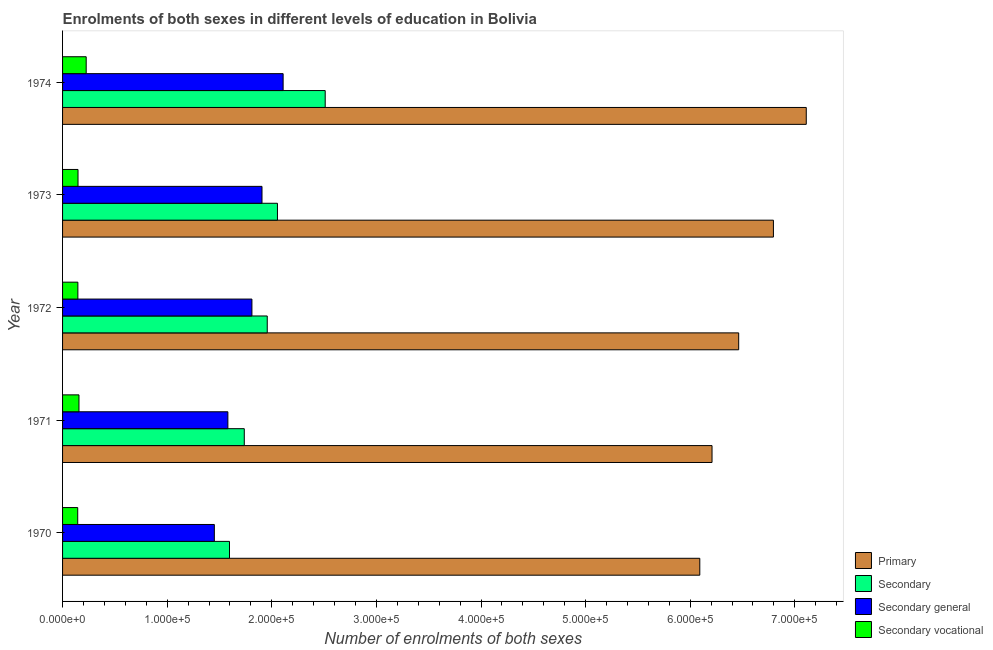How many different coloured bars are there?
Make the answer very short. 4. How many groups of bars are there?
Your answer should be compact. 5. Are the number of bars per tick equal to the number of legend labels?
Your response must be concise. Yes. How many bars are there on the 1st tick from the bottom?
Make the answer very short. 4. What is the label of the 3rd group of bars from the top?
Keep it short and to the point. 1972. What is the number of enrolments in secondary general education in 1970?
Your answer should be very brief. 1.45e+05. Across all years, what is the maximum number of enrolments in secondary vocational education?
Provide a short and direct response. 2.26e+04. Across all years, what is the minimum number of enrolments in secondary vocational education?
Your response must be concise. 1.45e+04. In which year was the number of enrolments in secondary vocational education maximum?
Make the answer very short. 1974. In which year was the number of enrolments in primary education minimum?
Offer a terse response. 1970. What is the total number of enrolments in primary education in the graph?
Provide a succinct answer. 3.27e+06. What is the difference between the number of enrolments in secondary general education in 1970 and that in 1974?
Provide a succinct answer. -6.57e+04. What is the difference between the number of enrolments in secondary education in 1973 and the number of enrolments in secondary general education in 1971?
Provide a short and direct response. 4.74e+04. What is the average number of enrolments in primary education per year?
Provide a short and direct response. 6.53e+05. In the year 1974, what is the difference between the number of enrolments in primary education and number of enrolments in secondary education?
Provide a short and direct response. 4.60e+05. What is the ratio of the number of enrolments in secondary education in 1972 to that in 1973?
Give a very brief answer. 0.95. What is the difference between the highest and the second highest number of enrolments in secondary vocational education?
Your answer should be compact. 6914. What is the difference between the highest and the lowest number of enrolments in secondary vocational education?
Your answer should be very brief. 8103. In how many years, is the number of enrolments in secondary vocational education greater than the average number of enrolments in secondary vocational education taken over all years?
Keep it short and to the point. 1. Is it the case that in every year, the sum of the number of enrolments in secondary general education and number of enrolments in secondary education is greater than the sum of number of enrolments in secondary vocational education and number of enrolments in primary education?
Offer a terse response. No. What does the 3rd bar from the top in 1973 represents?
Your response must be concise. Secondary. What does the 2nd bar from the bottom in 1971 represents?
Provide a succinct answer. Secondary. Is it the case that in every year, the sum of the number of enrolments in primary education and number of enrolments in secondary education is greater than the number of enrolments in secondary general education?
Your answer should be compact. Yes. How many bars are there?
Your response must be concise. 20. How many years are there in the graph?
Ensure brevity in your answer.  5. Does the graph contain any zero values?
Give a very brief answer. No. Where does the legend appear in the graph?
Offer a very short reply. Bottom right. How many legend labels are there?
Offer a terse response. 4. How are the legend labels stacked?
Provide a succinct answer. Vertical. What is the title of the graph?
Your answer should be very brief. Enrolments of both sexes in different levels of education in Bolivia. What is the label or title of the X-axis?
Keep it short and to the point. Number of enrolments of both sexes. What is the label or title of the Y-axis?
Offer a terse response. Year. What is the Number of enrolments of both sexes of Primary in 1970?
Ensure brevity in your answer.  6.09e+05. What is the Number of enrolments of both sexes in Secondary in 1970?
Ensure brevity in your answer.  1.60e+05. What is the Number of enrolments of both sexes in Secondary general in 1970?
Make the answer very short. 1.45e+05. What is the Number of enrolments of both sexes of Secondary vocational in 1970?
Keep it short and to the point. 1.45e+04. What is the Number of enrolments of both sexes in Primary in 1971?
Make the answer very short. 6.21e+05. What is the Number of enrolments of both sexes in Secondary in 1971?
Ensure brevity in your answer.  1.74e+05. What is the Number of enrolments of both sexes of Secondary general in 1971?
Your answer should be very brief. 1.58e+05. What is the Number of enrolments of both sexes in Secondary vocational in 1971?
Your response must be concise. 1.57e+04. What is the Number of enrolments of both sexes in Primary in 1972?
Your answer should be very brief. 6.46e+05. What is the Number of enrolments of both sexes of Secondary in 1972?
Your answer should be very brief. 1.96e+05. What is the Number of enrolments of both sexes of Secondary general in 1972?
Keep it short and to the point. 1.81e+05. What is the Number of enrolments of both sexes in Secondary vocational in 1972?
Ensure brevity in your answer.  1.46e+04. What is the Number of enrolments of both sexes of Primary in 1973?
Your answer should be compact. 6.80e+05. What is the Number of enrolments of both sexes in Secondary in 1973?
Give a very brief answer. 2.05e+05. What is the Number of enrolments of both sexes of Secondary general in 1973?
Provide a short and direct response. 1.91e+05. What is the Number of enrolments of both sexes of Secondary vocational in 1973?
Offer a very short reply. 1.48e+04. What is the Number of enrolments of both sexes in Primary in 1974?
Provide a short and direct response. 7.11e+05. What is the Number of enrolments of both sexes of Secondary in 1974?
Make the answer very short. 2.51e+05. What is the Number of enrolments of both sexes of Secondary general in 1974?
Your answer should be compact. 2.11e+05. What is the Number of enrolments of both sexes of Secondary vocational in 1974?
Provide a succinct answer. 2.26e+04. Across all years, what is the maximum Number of enrolments of both sexes of Primary?
Your answer should be compact. 7.11e+05. Across all years, what is the maximum Number of enrolments of both sexes in Secondary?
Offer a very short reply. 2.51e+05. Across all years, what is the maximum Number of enrolments of both sexes of Secondary general?
Provide a succinct answer. 2.11e+05. Across all years, what is the maximum Number of enrolments of both sexes in Secondary vocational?
Your answer should be very brief. 2.26e+04. Across all years, what is the minimum Number of enrolments of both sexes of Primary?
Give a very brief answer. 6.09e+05. Across all years, what is the minimum Number of enrolments of both sexes in Secondary?
Offer a very short reply. 1.60e+05. Across all years, what is the minimum Number of enrolments of both sexes in Secondary general?
Make the answer very short. 1.45e+05. Across all years, what is the minimum Number of enrolments of both sexes in Secondary vocational?
Make the answer very short. 1.45e+04. What is the total Number of enrolments of both sexes of Primary in the graph?
Offer a very short reply. 3.27e+06. What is the total Number of enrolments of both sexes of Secondary in the graph?
Your answer should be compact. 9.85e+05. What is the total Number of enrolments of both sexes in Secondary general in the graph?
Offer a terse response. 8.86e+05. What is the total Number of enrolments of both sexes of Secondary vocational in the graph?
Provide a succinct answer. 8.22e+04. What is the difference between the Number of enrolments of both sexes of Primary in 1970 and that in 1971?
Ensure brevity in your answer.  -1.17e+04. What is the difference between the Number of enrolments of both sexes in Secondary in 1970 and that in 1971?
Your response must be concise. -1.41e+04. What is the difference between the Number of enrolments of both sexes of Secondary general in 1970 and that in 1971?
Provide a succinct answer. -1.29e+04. What is the difference between the Number of enrolments of both sexes of Secondary vocational in 1970 and that in 1971?
Ensure brevity in your answer.  -1189. What is the difference between the Number of enrolments of both sexes of Primary in 1970 and that in 1972?
Give a very brief answer. -3.72e+04. What is the difference between the Number of enrolments of both sexes in Secondary in 1970 and that in 1972?
Ensure brevity in your answer.  -3.61e+04. What is the difference between the Number of enrolments of both sexes of Secondary general in 1970 and that in 1972?
Your answer should be very brief. -3.59e+04. What is the difference between the Number of enrolments of both sexes of Secondary vocational in 1970 and that in 1972?
Ensure brevity in your answer.  -157. What is the difference between the Number of enrolments of both sexes in Primary in 1970 and that in 1973?
Ensure brevity in your answer.  -7.04e+04. What is the difference between the Number of enrolments of both sexes in Secondary in 1970 and that in 1973?
Your answer should be very brief. -4.58e+04. What is the difference between the Number of enrolments of both sexes of Secondary general in 1970 and that in 1973?
Your answer should be compact. -4.56e+04. What is the difference between the Number of enrolments of both sexes in Secondary vocational in 1970 and that in 1973?
Your answer should be very brief. -288. What is the difference between the Number of enrolments of both sexes in Primary in 1970 and that in 1974?
Your answer should be very brief. -1.02e+05. What is the difference between the Number of enrolments of both sexes in Secondary in 1970 and that in 1974?
Your answer should be compact. -9.15e+04. What is the difference between the Number of enrolments of both sexes of Secondary general in 1970 and that in 1974?
Offer a very short reply. -6.57e+04. What is the difference between the Number of enrolments of both sexes in Secondary vocational in 1970 and that in 1974?
Keep it short and to the point. -8103. What is the difference between the Number of enrolments of both sexes in Primary in 1971 and that in 1972?
Give a very brief answer. -2.55e+04. What is the difference between the Number of enrolments of both sexes in Secondary in 1971 and that in 1972?
Provide a short and direct response. -2.20e+04. What is the difference between the Number of enrolments of both sexes of Secondary general in 1971 and that in 1972?
Make the answer very short. -2.30e+04. What is the difference between the Number of enrolments of both sexes in Secondary vocational in 1971 and that in 1972?
Keep it short and to the point. 1032. What is the difference between the Number of enrolments of both sexes in Primary in 1971 and that in 1973?
Offer a very short reply. -5.87e+04. What is the difference between the Number of enrolments of both sexes in Secondary in 1971 and that in 1973?
Ensure brevity in your answer.  -3.17e+04. What is the difference between the Number of enrolments of both sexes in Secondary general in 1971 and that in 1973?
Your answer should be compact. -3.26e+04. What is the difference between the Number of enrolments of both sexes in Secondary vocational in 1971 and that in 1973?
Give a very brief answer. 901. What is the difference between the Number of enrolments of both sexes in Primary in 1971 and that in 1974?
Offer a terse response. -9.01e+04. What is the difference between the Number of enrolments of both sexes in Secondary in 1971 and that in 1974?
Your answer should be compact. -7.74e+04. What is the difference between the Number of enrolments of both sexes in Secondary general in 1971 and that in 1974?
Provide a short and direct response. -5.28e+04. What is the difference between the Number of enrolments of both sexes of Secondary vocational in 1971 and that in 1974?
Offer a terse response. -6914. What is the difference between the Number of enrolments of both sexes in Primary in 1972 and that in 1973?
Your answer should be very brief. -3.32e+04. What is the difference between the Number of enrolments of both sexes in Secondary in 1972 and that in 1973?
Provide a short and direct response. -9761. What is the difference between the Number of enrolments of both sexes in Secondary general in 1972 and that in 1973?
Your response must be concise. -9630. What is the difference between the Number of enrolments of both sexes in Secondary vocational in 1972 and that in 1973?
Your answer should be very brief. -131. What is the difference between the Number of enrolments of both sexes of Primary in 1972 and that in 1974?
Make the answer very short. -6.46e+04. What is the difference between the Number of enrolments of both sexes of Secondary in 1972 and that in 1974?
Offer a very short reply. -5.54e+04. What is the difference between the Number of enrolments of both sexes of Secondary general in 1972 and that in 1974?
Your answer should be compact. -2.98e+04. What is the difference between the Number of enrolments of both sexes in Secondary vocational in 1972 and that in 1974?
Keep it short and to the point. -7946. What is the difference between the Number of enrolments of both sexes of Primary in 1973 and that in 1974?
Give a very brief answer. -3.14e+04. What is the difference between the Number of enrolments of both sexes of Secondary in 1973 and that in 1974?
Ensure brevity in your answer.  -4.56e+04. What is the difference between the Number of enrolments of both sexes of Secondary general in 1973 and that in 1974?
Provide a succinct answer. -2.02e+04. What is the difference between the Number of enrolments of both sexes in Secondary vocational in 1973 and that in 1974?
Your response must be concise. -7815. What is the difference between the Number of enrolments of both sexes of Primary in 1970 and the Number of enrolments of both sexes of Secondary in 1971?
Offer a terse response. 4.35e+05. What is the difference between the Number of enrolments of both sexes of Primary in 1970 and the Number of enrolments of both sexes of Secondary general in 1971?
Offer a very short reply. 4.51e+05. What is the difference between the Number of enrolments of both sexes in Primary in 1970 and the Number of enrolments of both sexes in Secondary vocational in 1971?
Ensure brevity in your answer.  5.94e+05. What is the difference between the Number of enrolments of both sexes in Secondary in 1970 and the Number of enrolments of both sexes in Secondary general in 1971?
Your answer should be very brief. 1545. What is the difference between the Number of enrolments of both sexes of Secondary in 1970 and the Number of enrolments of both sexes of Secondary vocational in 1971?
Offer a terse response. 1.44e+05. What is the difference between the Number of enrolments of both sexes in Secondary general in 1970 and the Number of enrolments of both sexes in Secondary vocational in 1971?
Give a very brief answer. 1.29e+05. What is the difference between the Number of enrolments of both sexes of Primary in 1970 and the Number of enrolments of both sexes of Secondary in 1972?
Offer a very short reply. 4.14e+05. What is the difference between the Number of enrolments of both sexes of Primary in 1970 and the Number of enrolments of both sexes of Secondary general in 1972?
Provide a short and direct response. 4.28e+05. What is the difference between the Number of enrolments of both sexes in Primary in 1970 and the Number of enrolments of both sexes in Secondary vocational in 1972?
Provide a succinct answer. 5.95e+05. What is the difference between the Number of enrolments of both sexes of Secondary in 1970 and the Number of enrolments of both sexes of Secondary general in 1972?
Your answer should be very brief. -2.14e+04. What is the difference between the Number of enrolments of both sexes in Secondary in 1970 and the Number of enrolments of both sexes in Secondary vocational in 1972?
Ensure brevity in your answer.  1.45e+05. What is the difference between the Number of enrolments of both sexes in Secondary general in 1970 and the Number of enrolments of both sexes in Secondary vocational in 1972?
Provide a short and direct response. 1.30e+05. What is the difference between the Number of enrolments of both sexes in Primary in 1970 and the Number of enrolments of both sexes in Secondary in 1973?
Provide a short and direct response. 4.04e+05. What is the difference between the Number of enrolments of both sexes of Primary in 1970 and the Number of enrolments of both sexes of Secondary general in 1973?
Provide a succinct answer. 4.19e+05. What is the difference between the Number of enrolments of both sexes of Primary in 1970 and the Number of enrolments of both sexes of Secondary vocational in 1973?
Provide a succinct answer. 5.94e+05. What is the difference between the Number of enrolments of both sexes in Secondary in 1970 and the Number of enrolments of both sexes in Secondary general in 1973?
Provide a short and direct response. -3.11e+04. What is the difference between the Number of enrolments of both sexes of Secondary in 1970 and the Number of enrolments of both sexes of Secondary vocational in 1973?
Offer a very short reply. 1.45e+05. What is the difference between the Number of enrolments of both sexes of Secondary general in 1970 and the Number of enrolments of both sexes of Secondary vocational in 1973?
Make the answer very short. 1.30e+05. What is the difference between the Number of enrolments of both sexes in Primary in 1970 and the Number of enrolments of both sexes in Secondary in 1974?
Provide a short and direct response. 3.58e+05. What is the difference between the Number of enrolments of both sexes of Primary in 1970 and the Number of enrolments of both sexes of Secondary general in 1974?
Make the answer very short. 3.98e+05. What is the difference between the Number of enrolments of both sexes of Primary in 1970 and the Number of enrolments of both sexes of Secondary vocational in 1974?
Offer a terse response. 5.87e+05. What is the difference between the Number of enrolments of both sexes in Secondary in 1970 and the Number of enrolments of both sexes in Secondary general in 1974?
Offer a terse response. -5.13e+04. What is the difference between the Number of enrolments of both sexes of Secondary in 1970 and the Number of enrolments of both sexes of Secondary vocational in 1974?
Make the answer very short. 1.37e+05. What is the difference between the Number of enrolments of both sexes of Secondary general in 1970 and the Number of enrolments of both sexes of Secondary vocational in 1974?
Give a very brief answer. 1.23e+05. What is the difference between the Number of enrolments of both sexes of Primary in 1971 and the Number of enrolments of both sexes of Secondary in 1972?
Make the answer very short. 4.25e+05. What is the difference between the Number of enrolments of both sexes of Primary in 1971 and the Number of enrolments of both sexes of Secondary general in 1972?
Ensure brevity in your answer.  4.40e+05. What is the difference between the Number of enrolments of both sexes in Primary in 1971 and the Number of enrolments of both sexes in Secondary vocational in 1972?
Your answer should be compact. 6.06e+05. What is the difference between the Number of enrolments of both sexes in Secondary in 1971 and the Number of enrolments of both sexes in Secondary general in 1972?
Your response must be concise. -7313. What is the difference between the Number of enrolments of both sexes of Secondary in 1971 and the Number of enrolments of both sexes of Secondary vocational in 1972?
Offer a terse response. 1.59e+05. What is the difference between the Number of enrolments of both sexes in Secondary general in 1971 and the Number of enrolments of both sexes in Secondary vocational in 1972?
Provide a short and direct response. 1.43e+05. What is the difference between the Number of enrolments of both sexes in Primary in 1971 and the Number of enrolments of both sexes in Secondary in 1973?
Make the answer very short. 4.15e+05. What is the difference between the Number of enrolments of both sexes of Primary in 1971 and the Number of enrolments of both sexes of Secondary general in 1973?
Offer a very short reply. 4.30e+05. What is the difference between the Number of enrolments of both sexes in Primary in 1971 and the Number of enrolments of both sexes in Secondary vocational in 1973?
Provide a succinct answer. 6.06e+05. What is the difference between the Number of enrolments of both sexes in Secondary in 1971 and the Number of enrolments of both sexes in Secondary general in 1973?
Offer a very short reply. -1.69e+04. What is the difference between the Number of enrolments of both sexes in Secondary in 1971 and the Number of enrolments of both sexes in Secondary vocational in 1973?
Your answer should be very brief. 1.59e+05. What is the difference between the Number of enrolments of both sexes in Secondary general in 1971 and the Number of enrolments of both sexes in Secondary vocational in 1973?
Make the answer very short. 1.43e+05. What is the difference between the Number of enrolments of both sexes in Primary in 1971 and the Number of enrolments of both sexes in Secondary in 1974?
Your answer should be compact. 3.70e+05. What is the difference between the Number of enrolments of both sexes in Primary in 1971 and the Number of enrolments of both sexes in Secondary general in 1974?
Provide a succinct answer. 4.10e+05. What is the difference between the Number of enrolments of both sexes of Primary in 1971 and the Number of enrolments of both sexes of Secondary vocational in 1974?
Provide a short and direct response. 5.98e+05. What is the difference between the Number of enrolments of both sexes of Secondary in 1971 and the Number of enrolments of both sexes of Secondary general in 1974?
Your response must be concise. -3.71e+04. What is the difference between the Number of enrolments of both sexes of Secondary in 1971 and the Number of enrolments of both sexes of Secondary vocational in 1974?
Ensure brevity in your answer.  1.51e+05. What is the difference between the Number of enrolments of both sexes in Secondary general in 1971 and the Number of enrolments of both sexes in Secondary vocational in 1974?
Offer a very short reply. 1.35e+05. What is the difference between the Number of enrolments of both sexes of Primary in 1972 and the Number of enrolments of both sexes of Secondary in 1973?
Your answer should be very brief. 4.41e+05. What is the difference between the Number of enrolments of both sexes of Primary in 1972 and the Number of enrolments of both sexes of Secondary general in 1973?
Provide a succinct answer. 4.56e+05. What is the difference between the Number of enrolments of both sexes in Primary in 1972 and the Number of enrolments of both sexes in Secondary vocational in 1973?
Offer a very short reply. 6.32e+05. What is the difference between the Number of enrolments of both sexes of Secondary in 1972 and the Number of enrolments of both sexes of Secondary general in 1973?
Your answer should be very brief. 5012. What is the difference between the Number of enrolments of both sexes in Secondary in 1972 and the Number of enrolments of both sexes in Secondary vocational in 1973?
Provide a succinct answer. 1.81e+05. What is the difference between the Number of enrolments of both sexes of Secondary general in 1972 and the Number of enrolments of both sexes of Secondary vocational in 1973?
Your answer should be very brief. 1.66e+05. What is the difference between the Number of enrolments of both sexes of Primary in 1972 and the Number of enrolments of both sexes of Secondary in 1974?
Keep it short and to the point. 3.95e+05. What is the difference between the Number of enrolments of both sexes in Primary in 1972 and the Number of enrolments of both sexes in Secondary general in 1974?
Make the answer very short. 4.36e+05. What is the difference between the Number of enrolments of both sexes of Primary in 1972 and the Number of enrolments of both sexes of Secondary vocational in 1974?
Provide a succinct answer. 6.24e+05. What is the difference between the Number of enrolments of both sexes in Secondary in 1972 and the Number of enrolments of both sexes in Secondary general in 1974?
Offer a very short reply. -1.52e+04. What is the difference between the Number of enrolments of both sexes in Secondary in 1972 and the Number of enrolments of both sexes in Secondary vocational in 1974?
Offer a terse response. 1.73e+05. What is the difference between the Number of enrolments of both sexes of Secondary general in 1972 and the Number of enrolments of both sexes of Secondary vocational in 1974?
Offer a terse response. 1.58e+05. What is the difference between the Number of enrolments of both sexes of Primary in 1973 and the Number of enrolments of both sexes of Secondary in 1974?
Your answer should be very brief. 4.28e+05. What is the difference between the Number of enrolments of both sexes in Primary in 1973 and the Number of enrolments of both sexes in Secondary general in 1974?
Your answer should be very brief. 4.69e+05. What is the difference between the Number of enrolments of both sexes in Primary in 1973 and the Number of enrolments of both sexes in Secondary vocational in 1974?
Provide a succinct answer. 6.57e+05. What is the difference between the Number of enrolments of both sexes in Secondary in 1973 and the Number of enrolments of both sexes in Secondary general in 1974?
Offer a terse response. -5415. What is the difference between the Number of enrolments of both sexes in Secondary in 1973 and the Number of enrolments of both sexes in Secondary vocational in 1974?
Your response must be concise. 1.83e+05. What is the difference between the Number of enrolments of both sexes of Secondary general in 1973 and the Number of enrolments of both sexes of Secondary vocational in 1974?
Your response must be concise. 1.68e+05. What is the average Number of enrolments of both sexes of Primary per year?
Offer a terse response. 6.53e+05. What is the average Number of enrolments of both sexes of Secondary per year?
Your answer should be compact. 1.97e+05. What is the average Number of enrolments of both sexes in Secondary general per year?
Keep it short and to the point. 1.77e+05. What is the average Number of enrolments of both sexes of Secondary vocational per year?
Give a very brief answer. 1.64e+04. In the year 1970, what is the difference between the Number of enrolments of both sexes in Primary and Number of enrolments of both sexes in Secondary?
Provide a succinct answer. 4.50e+05. In the year 1970, what is the difference between the Number of enrolments of both sexes in Primary and Number of enrolments of both sexes in Secondary general?
Your answer should be compact. 4.64e+05. In the year 1970, what is the difference between the Number of enrolments of both sexes of Primary and Number of enrolments of both sexes of Secondary vocational?
Your answer should be compact. 5.95e+05. In the year 1970, what is the difference between the Number of enrolments of both sexes of Secondary and Number of enrolments of both sexes of Secondary general?
Your answer should be compact. 1.45e+04. In the year 1970, what is the difference between the Number of enrolments of both sexes in Secondary and Number of enrolments of both sexes in Secondary vocational?
Provide a succinct answer. 1.45e+05. In the year 1970, what is the difference between the Number of enrolments of both sexes of Secondary general and Number of enrolments of both sexes of Secondary vocational?
Your answer should be very brief. 1.31e+05. In the year 1971, what is the difference between the Number of enrolments of both sexes of Primary and Number of enrolments of both sexes of Secondary?
Make the answer very short. 4.47e+05. In the year 1971, what is the difference between the Number of enrolments of both sexes in Primary and Number of enrolments of both sexes in Secondary general?
Offer a terse response. 4.63e+05. In the year 1971, what is the difference between the Number of enrolments of both sexes of Primary and Number of enrolments of both sexes of Secondary vocational?
Your answer should be very brief. 6.05e+05. In the year 1971, what is the difference between the Number of enrolments of both sexes in Secondary and Number of enrolments of both sexes in Secondary general?
Provide a short and direct response. 1.57e+04. In the year 1971, what is the difference between the Number of enrolments of both sexes of Secondary and Number of enrolments of both sexes of Secondary vocational?
Your response must be concise. 1.58e+05. In the year 1971, what is the difference between the Number of enrolments of both sexes of Secondary general and Number of enrolments of both sexes of Secondary vocational?
Your answer should be very brief. 1.42e+05. In the year 1972, what is the difference between the Number of enrolments of both sexes of Primary and Number of enrolments of both sexes of Secondary?
Give a very brief answer. 4.51e+05. In the year 1972, what is the difference between the Number of enrolments of both sexes in Primary and Number of enrolments of both sexes in Secondary general?
Give a very brief answer. 4.65e+05. In the year 1972, what is the difference between the Number of enrolments of both sexes of Primary and Number of enrolments of both sexes of Secondary vocational?
Offer a terse response. 6.32e+05. In the year 1972, what is the difference between the Number of enrolments of both sexes in Secondary and Number of enrolments of both sexes in Secondary general?
Your answer should be compact. 1.46e+04. In the year 1972, what is the difference between the Number of enrolments of both sexes of Secondary and Number of enrolments of both sexes of Secondary vocational?
Offer a terse response. 1.81e+05. In the year 1972, what is the difference between the Number of enrolments of both sexes of Secondary general and Number of enrolments of both sexes of Secondary vocational?
Make the answer very short. 1.66e+05. In the year 1973, what is the difference between the Number of enrolments of both sexes in Primary and Number of enrolments of both sexes in Secondary?
Give a very brief answer. 4.74e+05. In the year 1973, what is the difference between the Number of enrolments of both sexes in Primary and Number of enrolments of both sexes in Secondary general?
Your answer should be very brief. 4.89e+05. In the year 1973, what is the difference between the Number of enrolments of both sexes in Primary and Number of enrolments of both sexes in Secondary vocational?
Make the answer very short. 6.65e+05. In the year 1973, what is the difference between the Number of enrolments of both sexes of Secondary and Number of enrolments of both sexes of Secondary general?
Ensure brevity in your answer.  1.48e+04. In the year 1973, what is the difference between the Number of enrolments of both sexes of Secondary and Number of enrolments of both sexes of Secondary vocational?
Ensure brevity in your answer.  1.91e+05. In the year 1973, what is the difference between the Number of enrolments of both sexes in Secondary general and Number of enrolments of both sexes in Secondary vocational?
Ensure brevity in your answer.  1.76e+05. In the year 1974, what is the difference between the Number of enrolments of both sexes of Primary and Number of enrolments of both sexes of Secondary?
Give a very brief answer. 4.60e+05. In the year 1974, what is the difference between the Number of enrolments of both sexes in Primary and Number of enrolments of both sexes in Secondary general?
Ensure brevity in your answer.  5.00e+05. In the year 1974, what is the difference between the Number of enrolments of both sexes of Primary and Number of enrolments of both sexes of Secondary vocational?
Provide a short and direct response. 6.88e+05. In the year 1974, what is the difference between the Number of enrolments of both sexes of Secondary and Number of enrolments of both sexes of Secondary general?
Give a very brief answer. 4.02e+04. In the year 1974, what is the difference between the Number of enrolments of both sexes in Secondary and Number of enrolments of both sexes in Secondary vocational?
Your answer should be very brief. 2.28e+05. In the year 1974, what is the difference between the Number of enrolments of both sexes in Secondary general and Number of enrolments of both sexes in Secondary vocational?
Provide a short and direct response. 1.88e+05. What is the ratio of the Number of enrolments of both sexes in Primary in 1970 to that in 1971?
Your answer should be very brief. 0.98. What is the ratio of the Number of enrolments of both sexes of Secondary in 1970 to that in 1971?
Make the answer very short. 0.92. What is the ratio of the Number of enrolments of both sexes of Secondary general in 1970 to that in 1971?
Make the answer very short. 0.92. What is the ratio of the Number of enrolments of both sexes of Secondary vocational in 1970 to that in 1971?
Your response must be concise. 0.92. What is the ratio of the Number of enrolments of both sexes of Primary in 1970 to that in 1972?
Offer a terse response. 0.94. What is the ratio of the Number of enrolments of both sexes of Secondary in 1970 to that in 1972?
Keep it short and to the point. 0.82. What is the ratio of the Number of enrolments of both sexes of Secondary general in 1970 to that in 1972?
Provide a short and direct response. 0.8. What is the ratio of the Number of enrolments of both sexes in Secondary vocational in 1970 to that in 1972?
Keep it short and to the point. 0.99. What is the ratio of the Number of enrolments of both sexes in Primary in 1970 to that in 1973?
Ensure brevity in your answer.  0.9. What is the ratio of the Number of enrolments of both sexes of Secondary in 1970 to that in 1973?
Make the answer very short. 0.78. What is the ratio of the Number of enrolments of both sexes in Secondary general in 1970 to that in 1973?
Your answer should be compact. 0.76. What is the ratio of the Number of enrolments of both sexes in Secondary vocational in 1970 to that in 1973?
Make the answer very short. 0.98. What is the ratio of the Number of enrolments of both sexes of Primary in 1970 to that in 1974?
Offer a very short reply. 0.86. What is the ratio of the Number of enrolments of both sexes in Secondary in 1970 to that in 1974?
Make the answer very short. 0.64. What is the ratio of the Number of enrolments of both sexes of Secondary general in 1970 to that in 1974?
Provide a succinct answer. 0.69. What is the ratio of the Number of enrolments of both sexes in Secondary vocational in 1970 to that in 1974?
Make the answer very short. 0.64. What is the ratio of the Number of enrolments of both sexes of Primary in 1971 to that in 1972?
Ensure brevity in your answer.  0.96. What is the ratio of the Number of enrolments of both sexes in Secondary in 1971 to that in 1972?
Provide a succinct answer. 0.89. What is the ratio of the Number of enrolments of both sexes in Secondary general in 1971 to that in 1972?
Your answer should be compact. 0.87. What is the ratio of the Number of enrolments of both sexes in Secondary vocational in 1971 to that in 1972?
Your answer should be very brief. 1.07. What is the ratio of the Number of enrolments of both sexes of Primary in 1971 to that in 1973?
Make the answer very short. 0.91. What is the ratio of the Number of enrolments of both sexes of Secondary in 1971 to that in 1973?
Give a very brief answer. 0.85. What is the ratio of the Number of enrolments of both sexes of Secondary general in 1971 to that in 1973?
Your answer should be very brief. 0.83. What is the ratio of the Number of enrolments of both sexes of Secondary vocational in 1971 to that in 1973?
Offer a very short reply. 1.06. What is the ratio of the Number of enrolments of both sexes in Primary in 1971 to that in 1974?
Offer a terse response. 0.87. What is the ratio of the Number of enrolments of both sexes in Secondary in 1971 to that in 1974?
Provide a succinct answer. 0.69. What is the ratio of the Number of enrolments of both sexes in Secondary general in 1971 to that in 1974?
Offer a terse response. 0.75. What is the ratio of the Number of enrolments of both sexes in Secondary vocational in 1971 to that in 1974?
Your answer should be very brief. 0.69. What is the ratio of the Number of enrolments of both sexes of Primary in 1972 to that in 1973?
Your answer should be very brief. 0.95. What is the ratio of the Number of enrolments of both sexes of Secondary in 1972 to that in 1973?
Give a very brief answer. 0.95. What is the ratio of the Number of enrolments of both sexes in Secondary general in 1972 to that in 1973?
Make the answer very short. 0.95. What is the ratio of the Number of enrolments of both sexes in Secondary in 1972 to that in 1974?
Provide a succinct answer. 0.78. What is the ratio of the Number of enrolments of both sexes of Secondary general in 1972 to that in 1974?
Offer a terse response. 0.86. What is the ratio of the Number of enrolments of both sexes in Secondary vocational in 1972 to that in 1974?
Give a very brief answer. 0.65. What is the ratio of the Number of enrolments of both sexes of Primary in 1973 to that in 1974?
Keep it short and to the point. 0.96. What is the ratio of the Number of enrolments of both sexes in Secondary in 1973 to that in 1974?
Offer a very short reply. 0.82. What is the ratio of the Number of enrolments of both sexes of Secondary general in 1973 to that in 1974?
Give a very brief answer. 0.9. What is the ratio of the Number of enrolments of both sexes in Secondary vocational in 1973 to that in 1974?
Ensure brevity in your answer.  0.65. What is the difference between the highest and the second highest Number of enrolments of both sexes in Primary?
Give a very brief answer. 3.14e+04. What is the difference between the highest and the second highest Number of enrolments of both sexes of Secondary?
Your response must be concise. 4.56e+04. What is the difference between the highest and the second highest Number of enrolments of both sexes in Secondary general?
Ensure brevity in your answer.  2.02e+04. What is the difference between the highest and the second highest Number of enrolments of both sexes in Secondary vocational?
Keep it short and to the point. 6914. What is the difference between the highest and the lowest Number of enrolments of both sexes of Primary?
Your answer should be compact. 1.02e+05. What is the difference between the highest and the lowest Number of enrolments of both sexes of Secondary?
Make the answer very short. 9.15e+04. What is the difference between the highest and the lowest Number of enrolments of both sexes in Secondary general?
Offer a very short reply. 6.57e+04. What is the difference between the highest and the lowest Number of enrolments of both sexes in Secondary vocational?
Make the answer very short. 8103. 